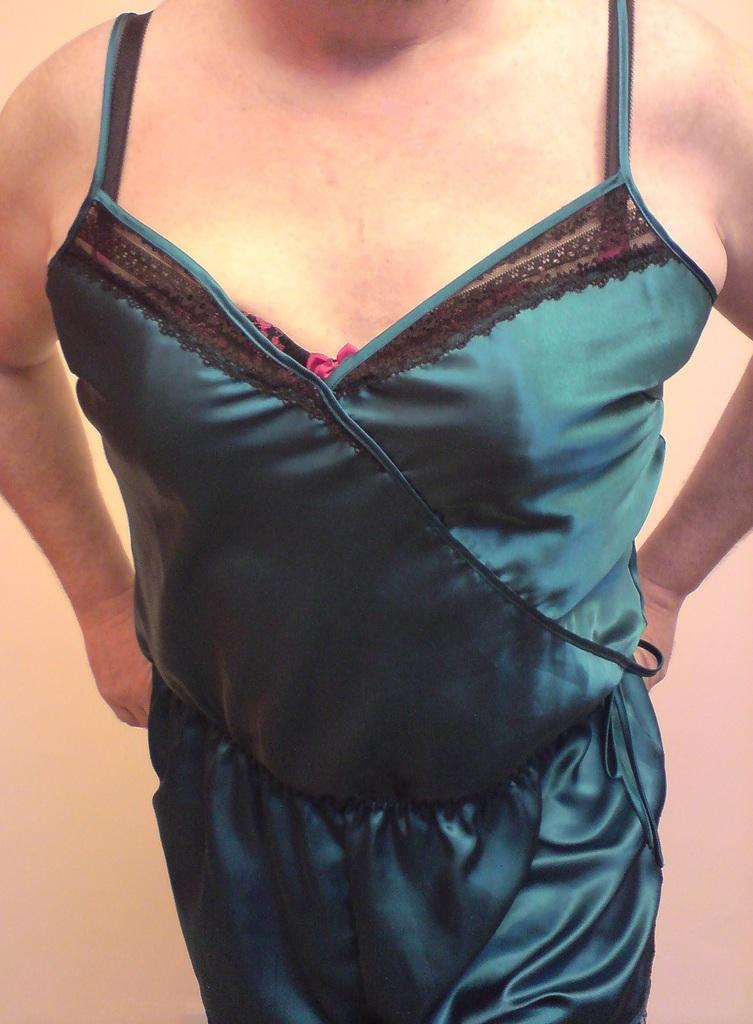Who or what is present in the image? There is a person in the image. What is the person doing in the image? The person is standing. What type of garden can be seen in the image? There is no garden present in the image; it only features a person standing. How deep is the hole that the person is standing in? There is no hole present in the image; the person is standing on a flat surface. 